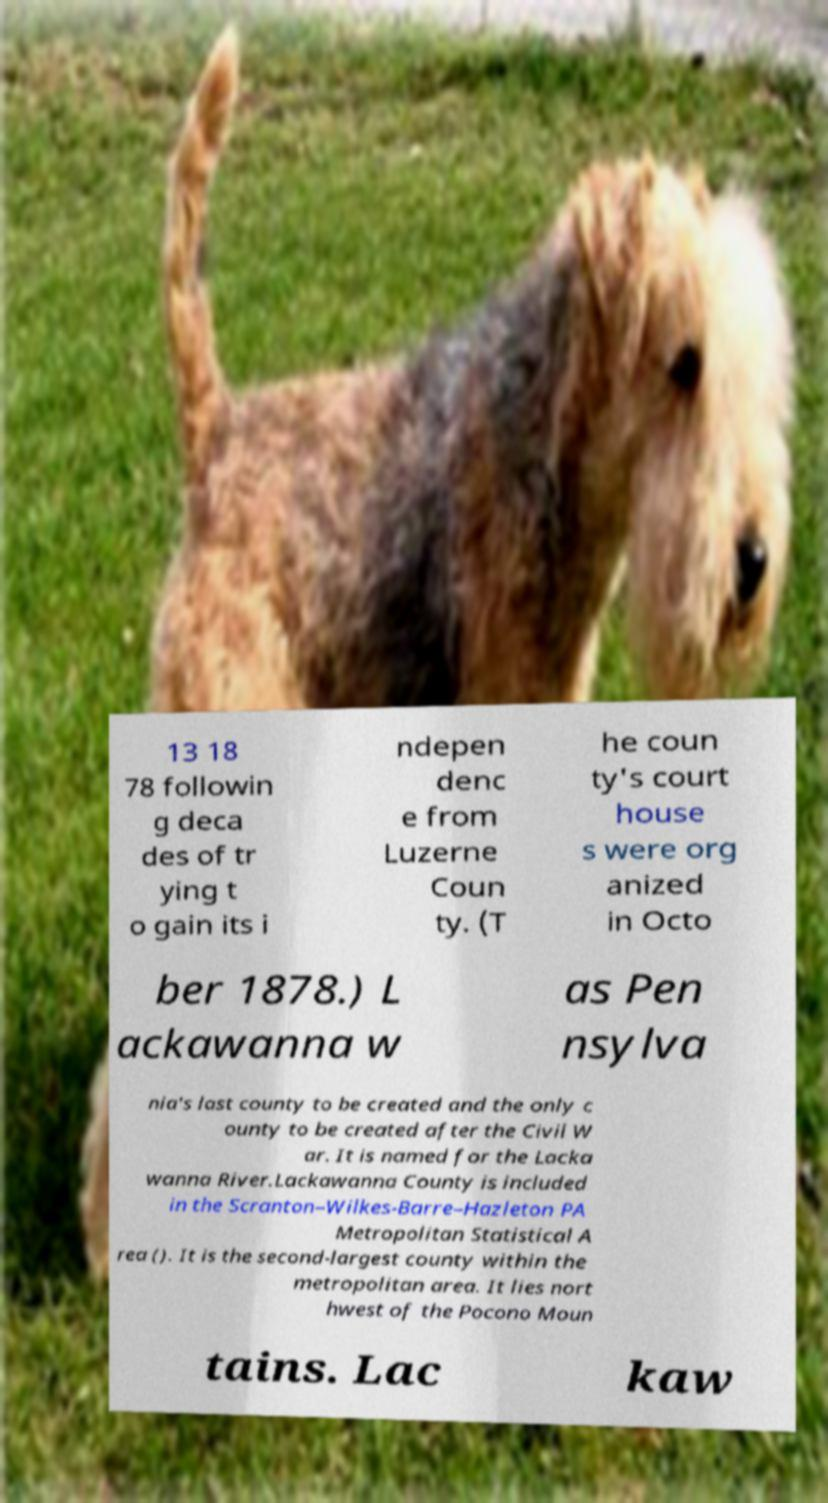Can you accurately transcribe the text from the provided image for me? 13 18 78 followin g deca des of tr ying t o gain its i ndepen denc e from Luzerne Coun ty. (T he coun ty's court house s were org anized in Octo ber 1878.) L ackawanna w as Pen nsylva nia's last county to be created and the only c ounty to be created after the Civil W ar. It is named for the Lacka wanna River.Lackawanna County is included in the Scranton–Wilkes-Barre–Hazleton PA Metropolitan Statistical A rea (). It is the second-largest county within the metropolitan area. It lies nort hwest of the Pocono Moun tains. Lac kaw 